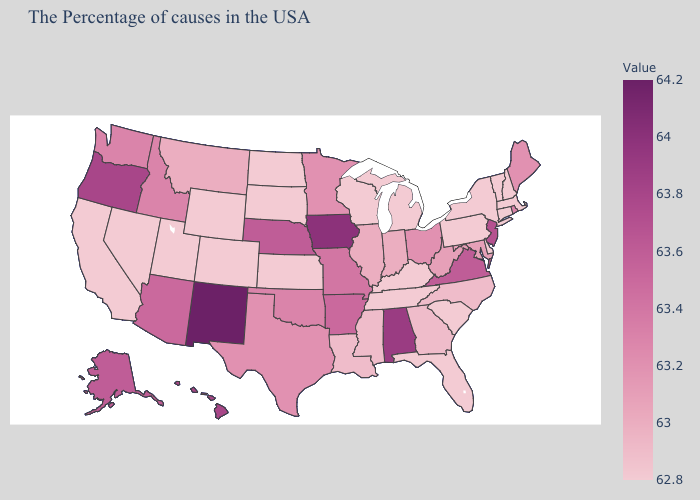Among the states that border Kansas , does Colorado have the lowest value?
Be succinct. Yes. Does New Hampshire have the lowest value in the Northeast?
Give a very brief answer. Yes. Is the legend a continuous bar?
Be succinct. Yes. Among the states that border Virginia , does Kentucky have the highest value?
Be succinct. No. Which states hav the highest value in the MidWest?
Keep it brief. Iowa. 